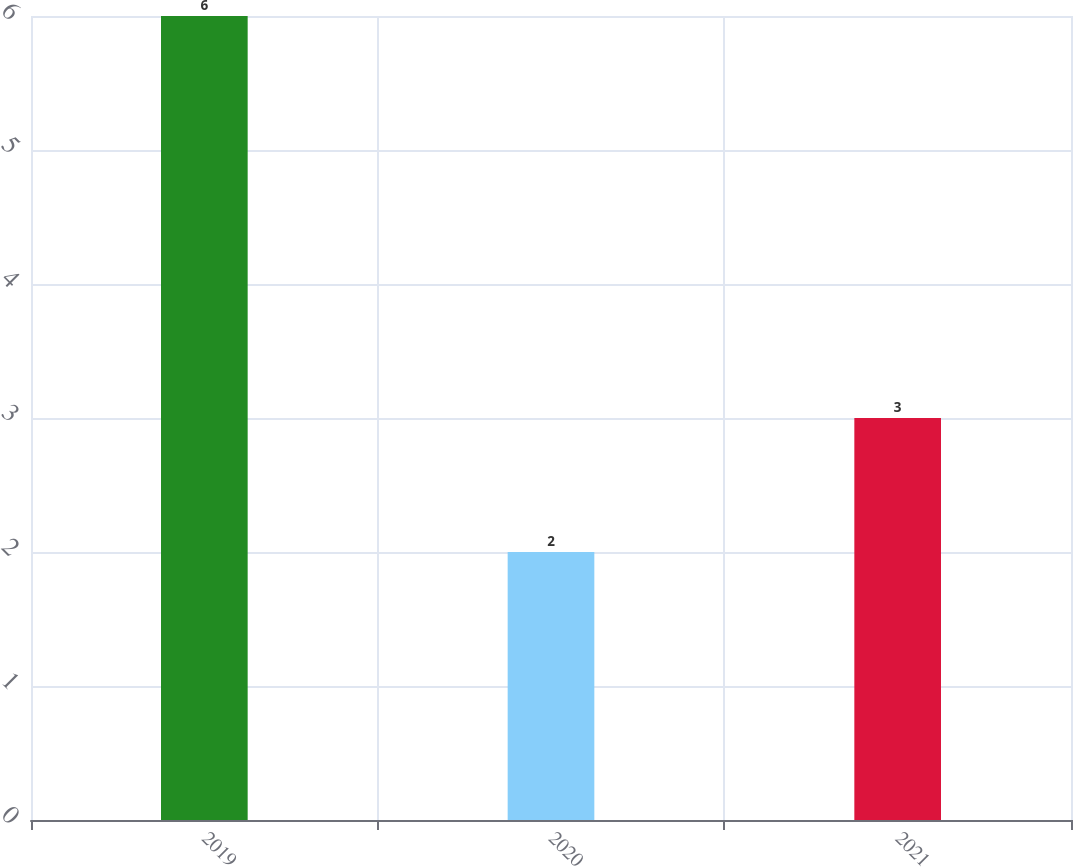Convert chart. <chart><loc_0><loc_0><loc_500><loc_500><bar_chart><fcel>2019<fcel>2020<fcel>2021<nl><fcel>6<fcel>2<fcel>3<nl></chart> 